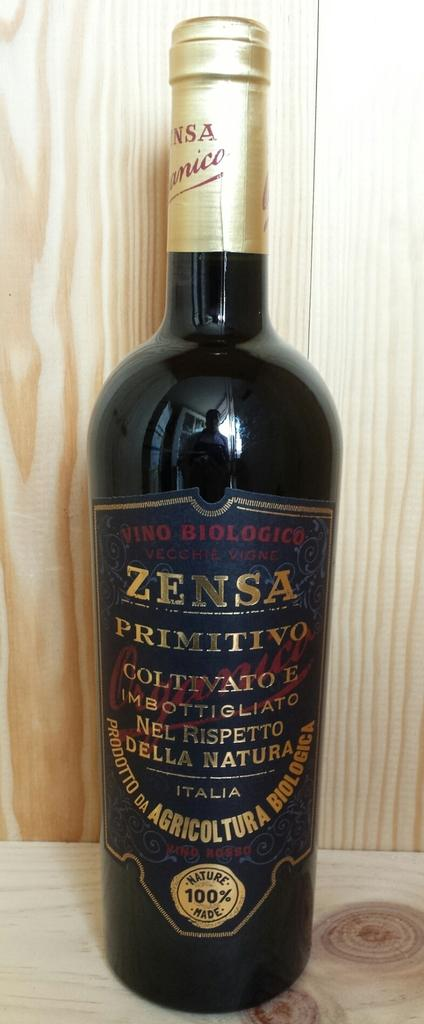Provide a one-sentence caption for the provided image. A black bottle of Zensa in front of a wooden wall. 